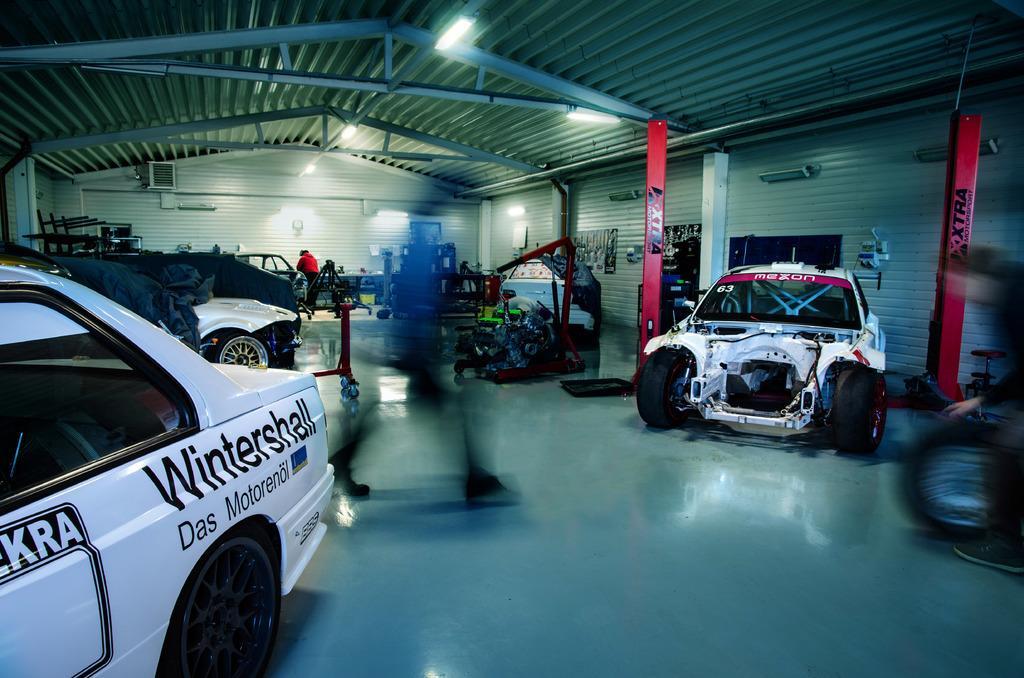How would you summarize this image in a sentence or two? Inside this shed there are vehicles and people. These people are in motion. Here we can see lights and things. 